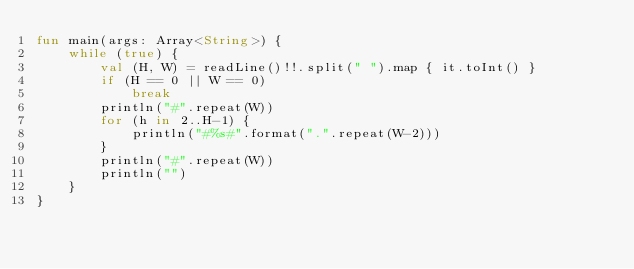Convert code to text. <code><loc_0><loc_0><loc_500><loc_500><_Kotlin_>fun main(args: Array<String>) {
    while (true) {
        val (H, W) = readLine()!!.split(" ").map { it.toInt() }
        if (H == 0 || W == 0)
            break
        println("#".repeat(W))
        for (h in 2..H-1) {
            println("#%s#".format(".".repeat(W-2)))
        }
        println("#".repeat(W))
        println("")
    }
}
</code> 